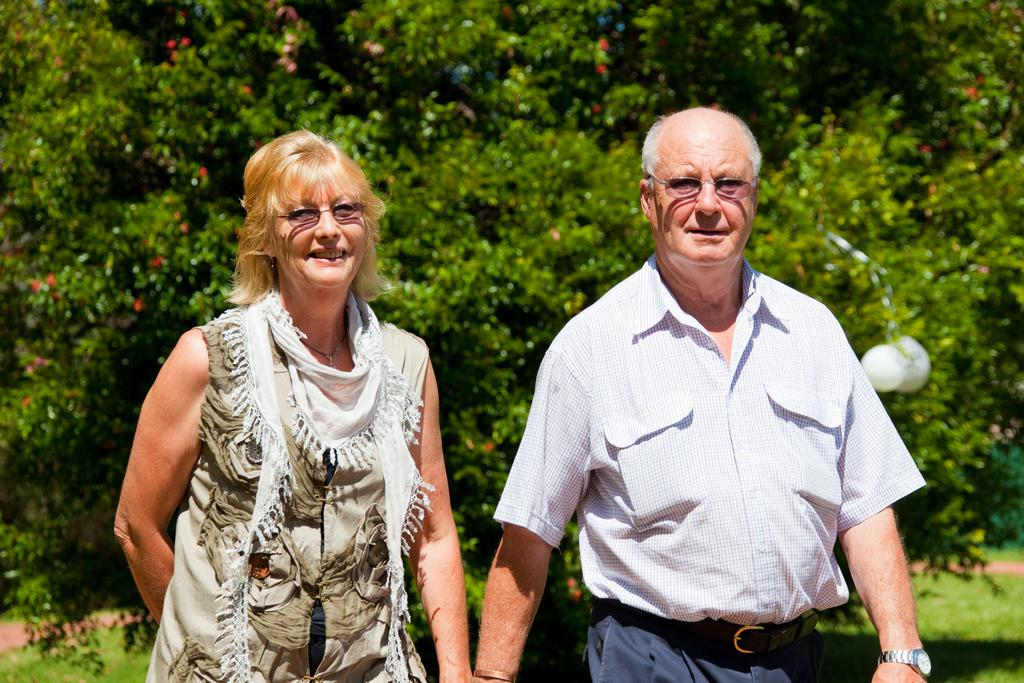How many people are in the image? There are two people in the image, a man and a woman. Where are the man and woman located in the image? The man and woman are in the middle of the image. What can be seen in the background of the image? There are trees in the background of the image. What type of dogs are playing with the man and woman in the image? There are no dogs present in the image; it only features a man and a woman. How does the sun affect the mood of the man and woman in the image? The image does not provide any information about the mood of the man and woman, nor does it mention the sun. 